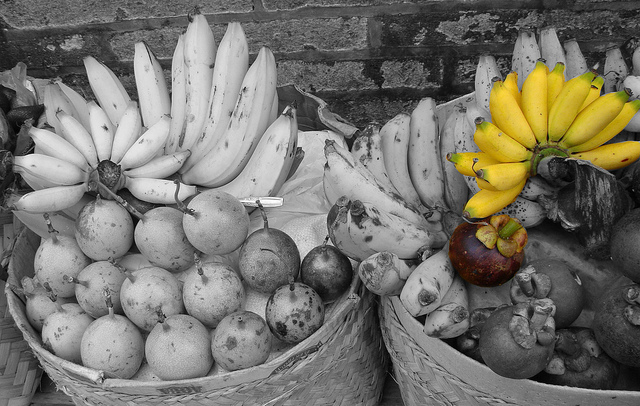<image>Are they on sale? I don't know if they are on sale. It can be both yes and no. Are they on sale? I don't know if they are on sale. It can be both yes or no. 